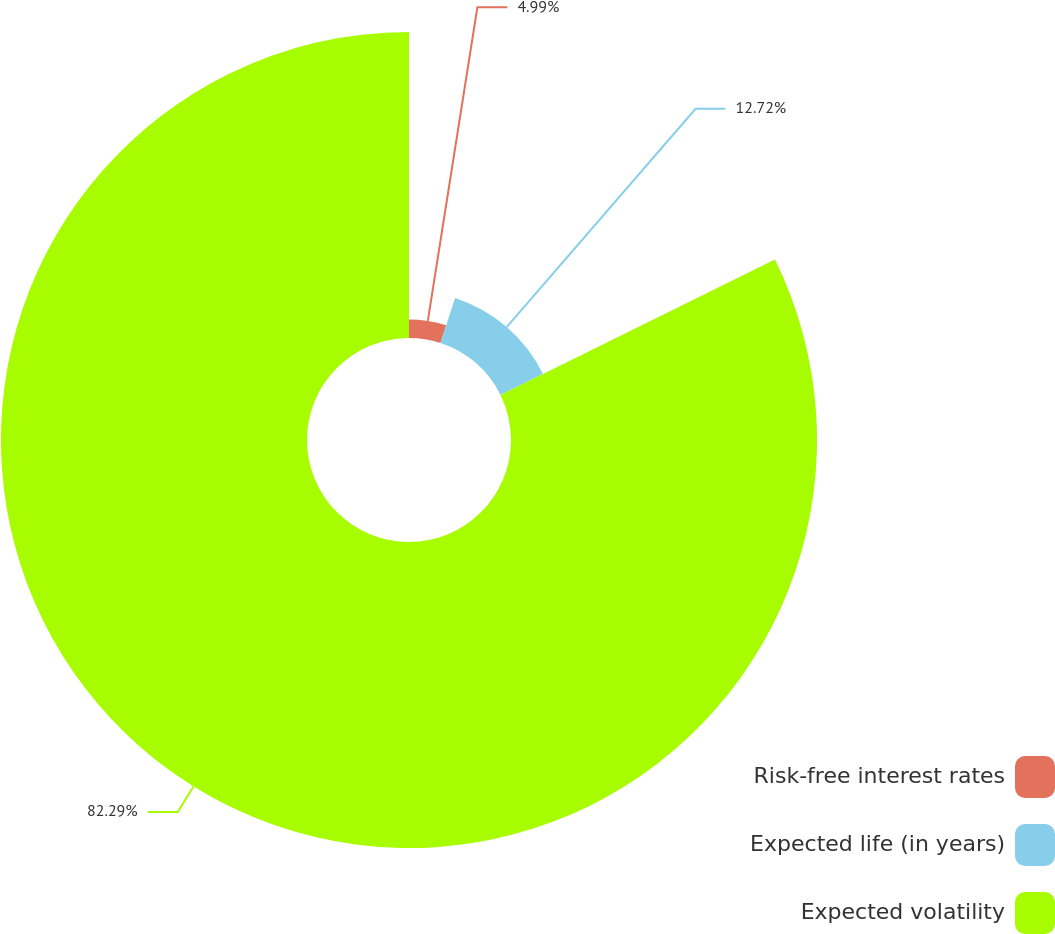<chart> <loc_0><loc_0><loc_500><loc_500><pie_chart><fcel>Risk-free interest rates<fcel>Expected life (in years)<fcel>Expected volatility<nl><fcel>4.99%<fcel>12.72%<fcel>82.29%<nl></chart> 